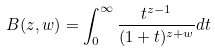<formula> <loc_0><loc_0><loc_500><loc_500>B ( z , w ) = \int _ { 0 } ^ { \infty } \frac { t ^ { z - 1 } } { ( 1 + t ) ^ { z + w } } d t</formula> 